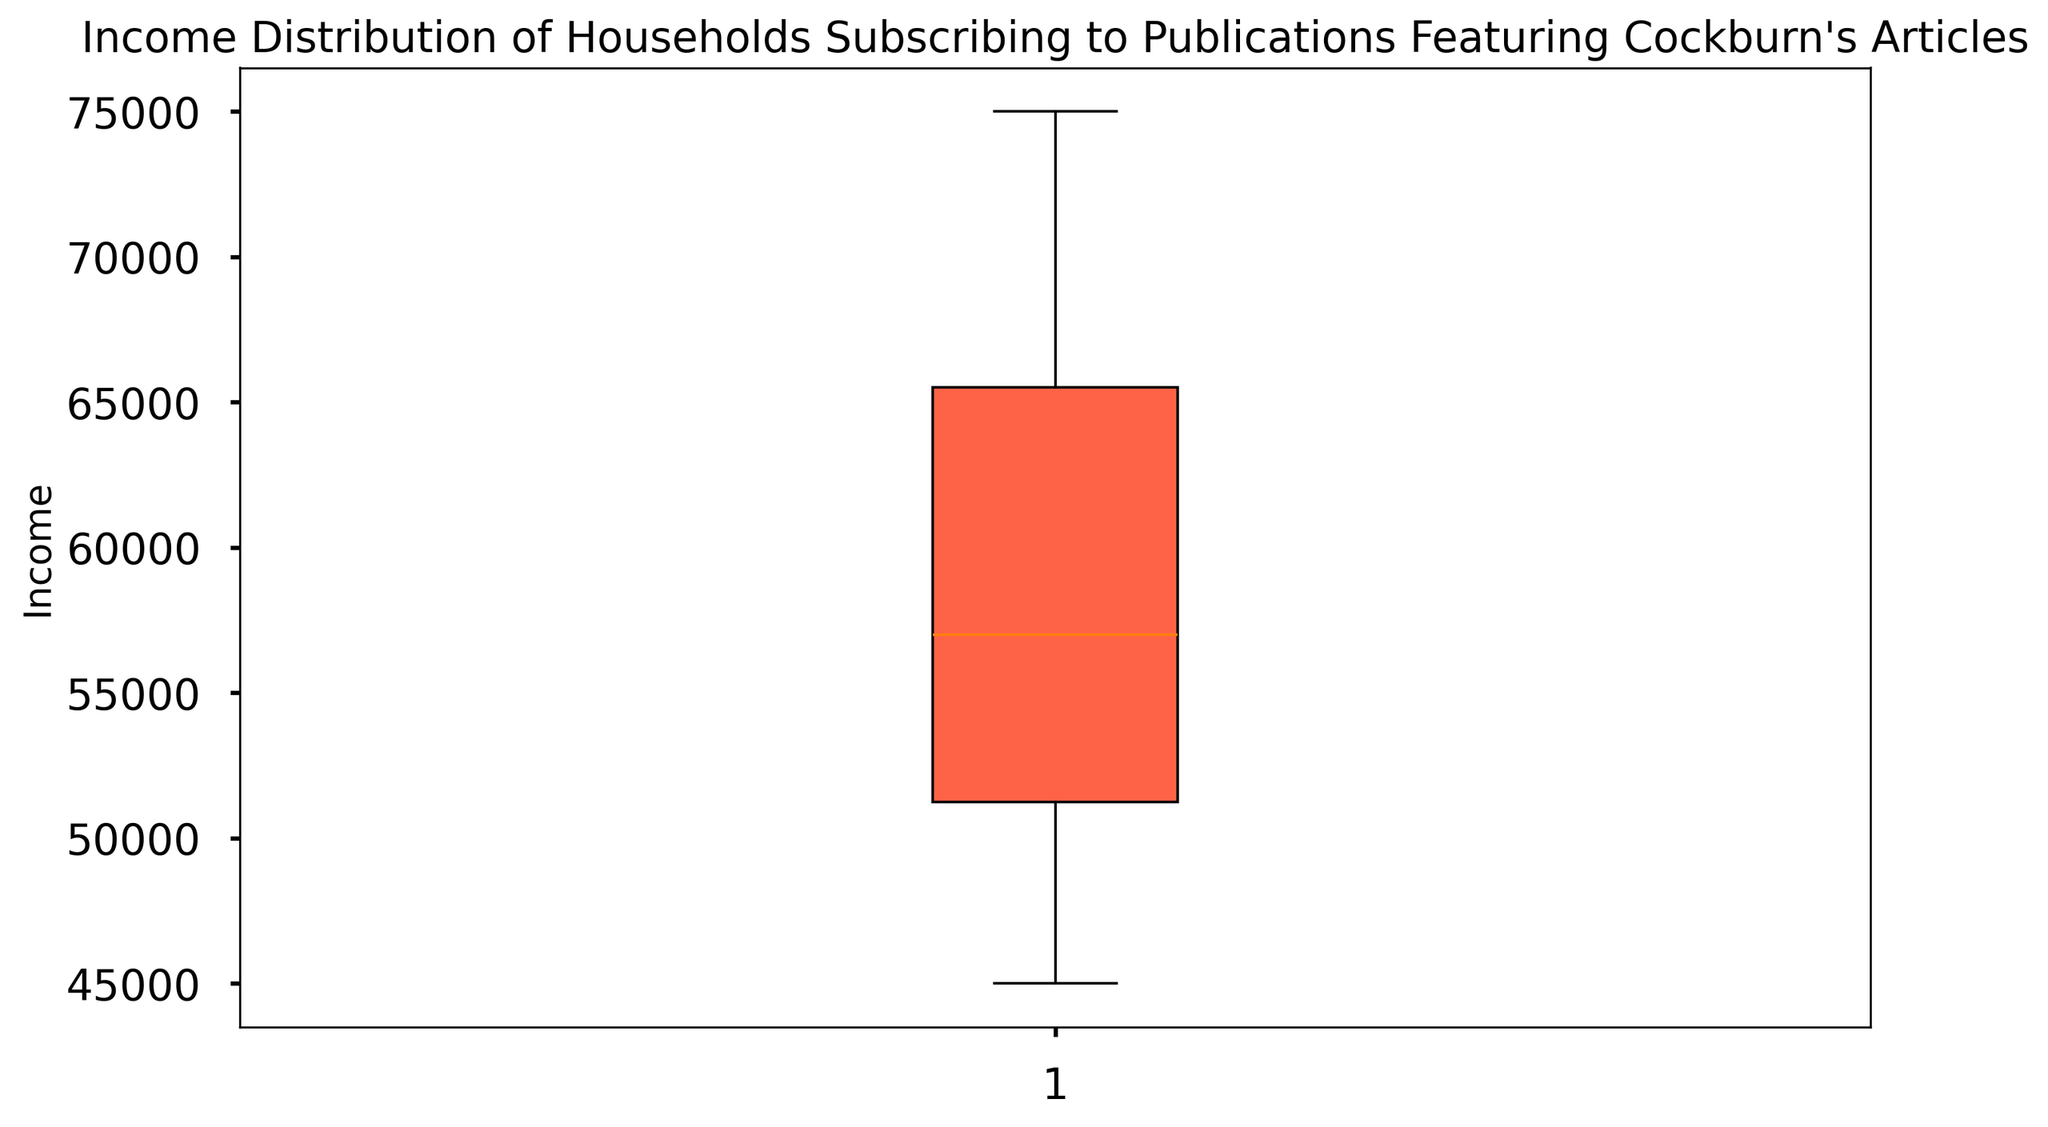What is the median income of the households in the plot? The median value is the middle value when the data is ordered from least to greatest. In a box plot, the median is depicted by the line inside the box. Look at the line in the middle of the box.
Answer: 57000 What is the range of incomes in the dataset? The range is the difference between the maximum and minimum values. In a box plot, these are represented by the top and bottom whiskers. Find the highest and lowest points of the whiskers and subtract the smallest value from the largest value.
Answer: 75000 - 45000 = 30000 What is the interquartile range (IQR) of the incomes? The IQR is the range between the first quartile (Q1) and the third quartile (Q3). These quartiles are represented by the bottom and top edges of the box, respectively. Find the values at the edges of the box and subtract Q1 from Q3.
Answer: 65000 - 51000 = 14000 Which value is greater, the median income or the mean of the incomes assuming normally distributed data? In a symmetric distribution, the mean and median are approximately equal. Looking at the median line in the box plot, we can compare it to the context of normal distribution and see if both would be centered around this value.
Answer: They should be approximately equal Are there any outliers in the income dataset? Outliers would be represented as individual points outside the whiskers of the box plot. Look to see if there are any standalone points on the plot.
Answer: No What is the income value at the 25th percentile (Q1)? The 25th percentile is represented by the bottom edge of the box in a box plot. Identify the value at this location on the plot.
Answer: 51000 What is the income value at the 75th percentile (Q3)? The 75th percentile is represented by the top edge of the box in a box plot. Identify the value at this location on the plot.
Answer: 65000 Is the distribution of income skewed? Skewness can be inferred from a box plot by comparing the median line's position within the box and the lengths of the whiskers. If the median is centered and whiskers are of equal length, the distribution isn't skewed. Otherwise, it is.
Answer: Slightly right-skewed How does the whisker length above the median compare to the whisker length below the median? Compare the lengths of the whiskers from the median line to the top and bottom ends. The whisker lengths indicate how data is spread out above and below the median.
Answer: Length above median is slightly longer 